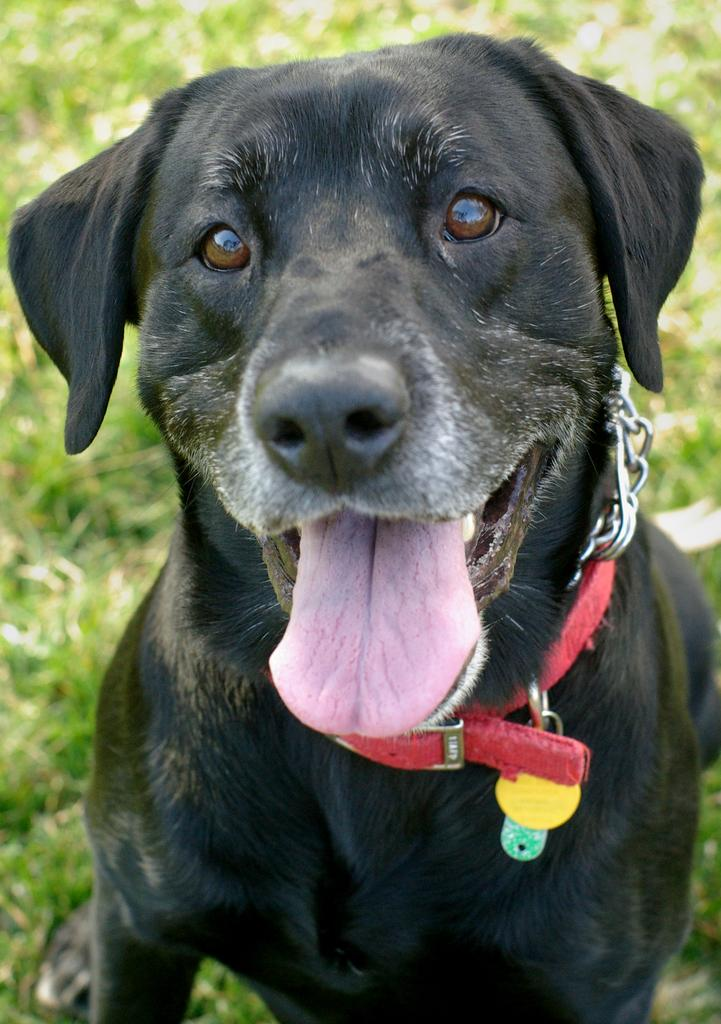What type of animal is present in the image? There is a dog in the image. What is attached to the dog's neck? The dog has a chain belt around its neck. What type of surface is visible behind the dog? There is grass on the surface behind the dog. What type of hat is the dog wearing in the image? There is no hat present in the image; the dog is wearing a chain belt around its neck. 